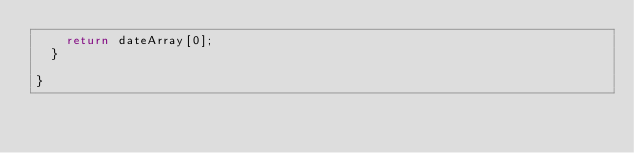<code> <loc_0><loc_0><loc_500><loc_500><_TypeScript_>    return dateArray[0];
  }

}
</code> 